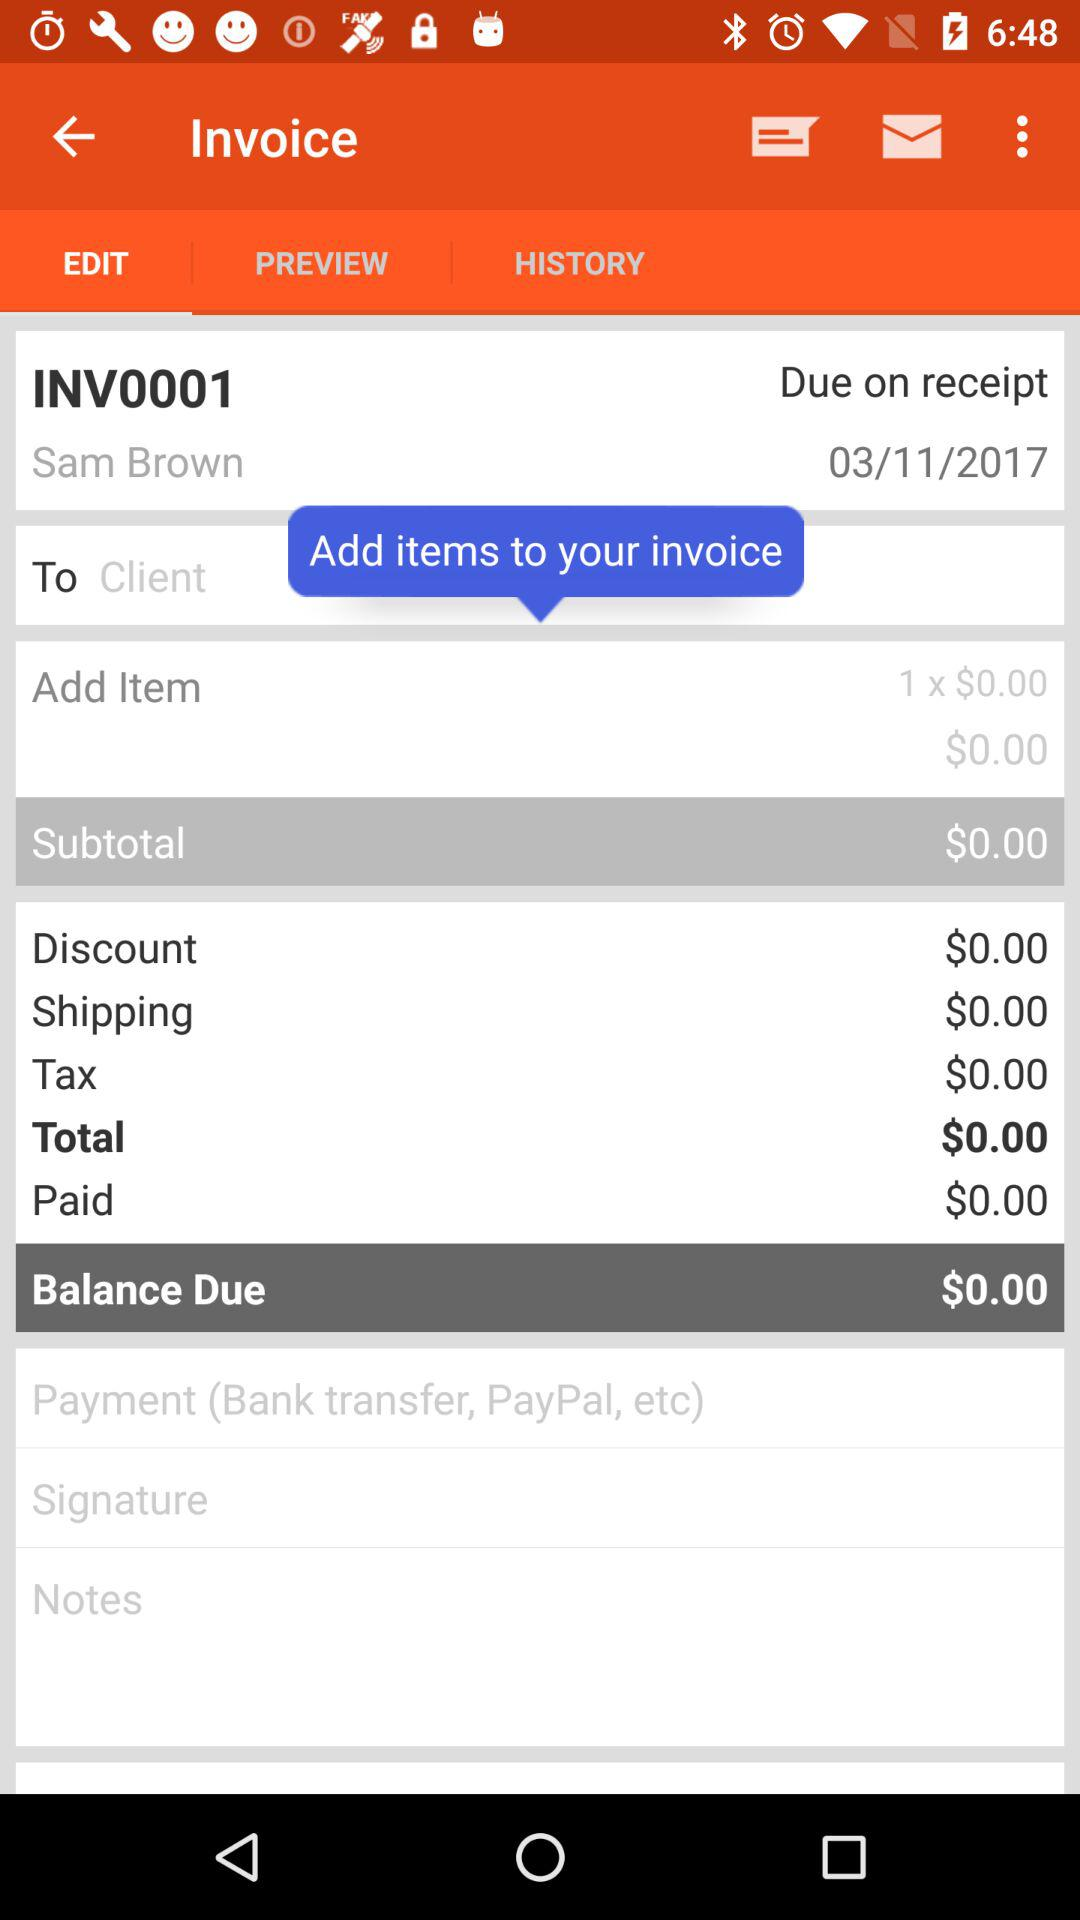On what date was the invoice created? The invoice was created on March 11, 2017. 